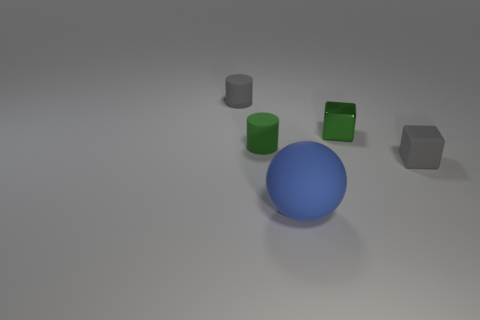There is a big blue matte thing; is its shape the same as the green thing on the left side of the blue object?
Your answer should be compact. No. There is a gray matte thing that is behind the rubber block; what is its shape?
Your answer should be compact. Cylinder. Is the tiny green metallic object the same shape as the big blue thing?
Your answer should be very brief. No. What is the size of the other matte object that is the same shape as the small green rubber object?
Make the answer very short. Small. There is a gray thing that is in front of the gray cylinder; is it the same size as the small green metal thing?
Ensure brevity in your answer.  Yes. There is a object that is in front of the small green cylinder and right of the sphere; what is its size?
Give a very brief answer. Small. What material is the tiny cylinder that is the same color as the tiny shiny thing?
Offer a very short reply. Rubber. How many tiny cylinders have the same color as the rubber cube?
Give a very brief answer. 1. Are there the same number of green things that are in front of the green rubber cylinder and large blue rubber spheres?
Provide a short and direct response. No. What is the color of the big rubber object?
Make the answer very short. Blue. 